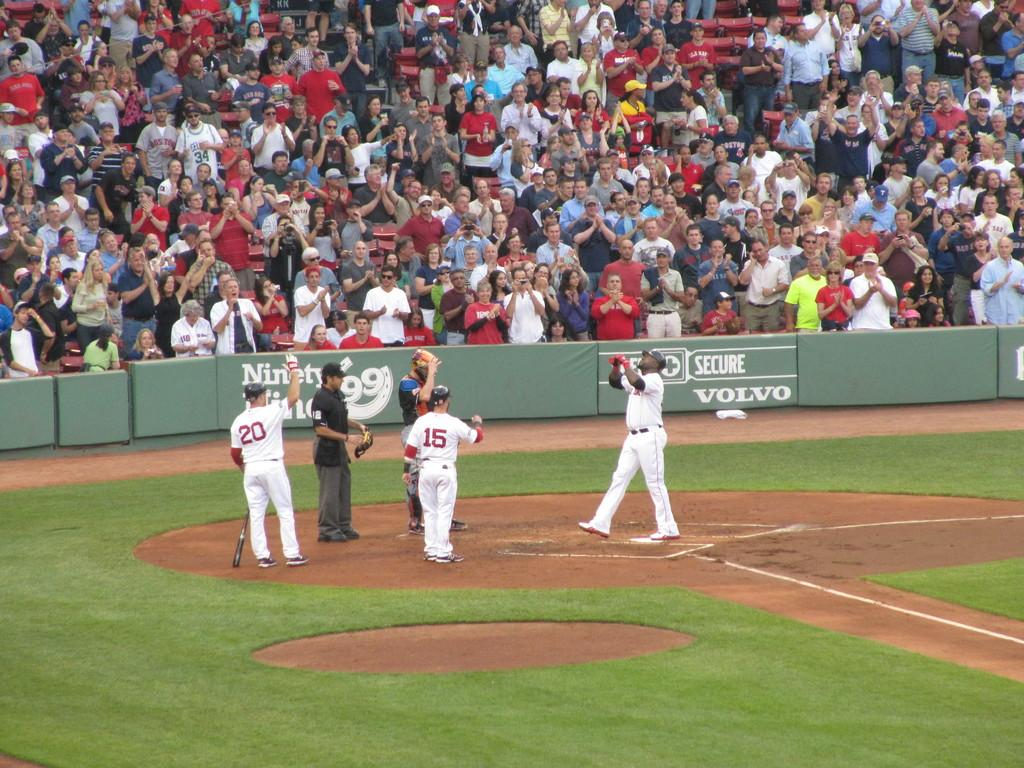<image>
Write a terse but informative summary of the picture. The bleachers at a baseball game have advertisements for Volvo and others on them. 